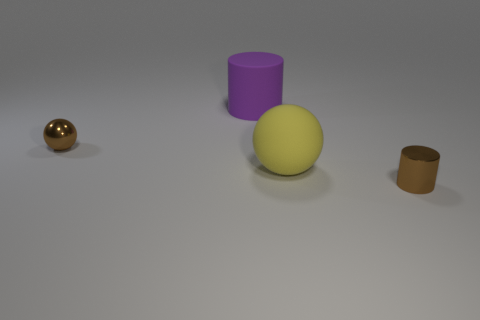Is the color of the small sphere the same as the shiny cylinder?
Your response must be concise. Yes. Is the material of the ball that is left of the large yellow matte ball the same as the yellow ball?
Give a very brief answer. No. Are there the same number of large yellow matte spheres to the left of the tiny brown metal sphere and small objects left of the brown metal cylinder?
Provide a succinct answer. No. How many yellow spheres are to the left of the metallic object left of the matte cylinder?
Provide a short and direct response. 0. There is a tiny metallic object that is on the left side of the purple rubber object; does it have the same color as the big rubber thing to the right of the purple rubber object?
Your answer should be compact. No. There is a purple object that is the same size as the yellow rubber thing; what material is it?
Offer a very short reply. Rubber. There is a thing left of the large purple rubber cylinder that is to the left of the shiny thing that is right of the purple cylinder; what is its shape?
Ensure brevity in your answer.  Sphere. What is the shape of the brown metal thing that is the same size as the brown shiny cylinder?
Give a very brief answer. Sphere. What number of metallic balls are on the right side of the small thing to the left of the matte thing behind the brown ball?
Your response must be concise. 0. Is the number of small brown metal things that are on the right side of the tiny brown sphere greater than the number of large purple objects that are on the left side of the big matte cylinder?
Provide a short and direct response. Yes. 